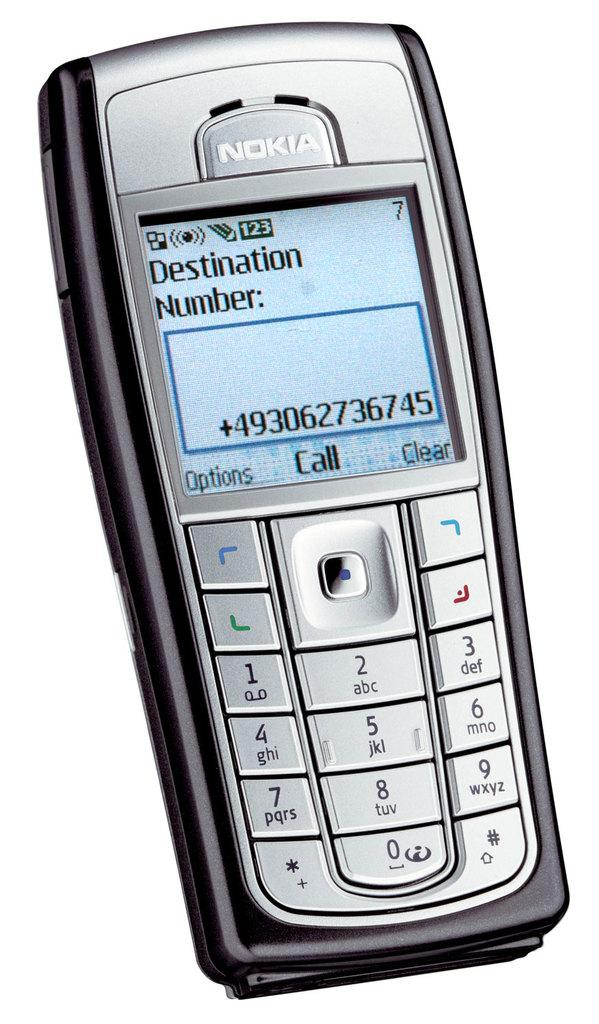What is the main subject of the image? The main subject of the image is a mobile. What type of statement is being made by the mobile in the image? The mobile in the image is not making any statements, as it is an inanimate object. 